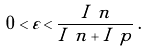<formula> <loc_0><loc_0><loc_500><loc_500>0 < \varepsilon < \frac { I _ { \ } n } { I _ { \ } n + I _ { \ } p } \, .</formula> 